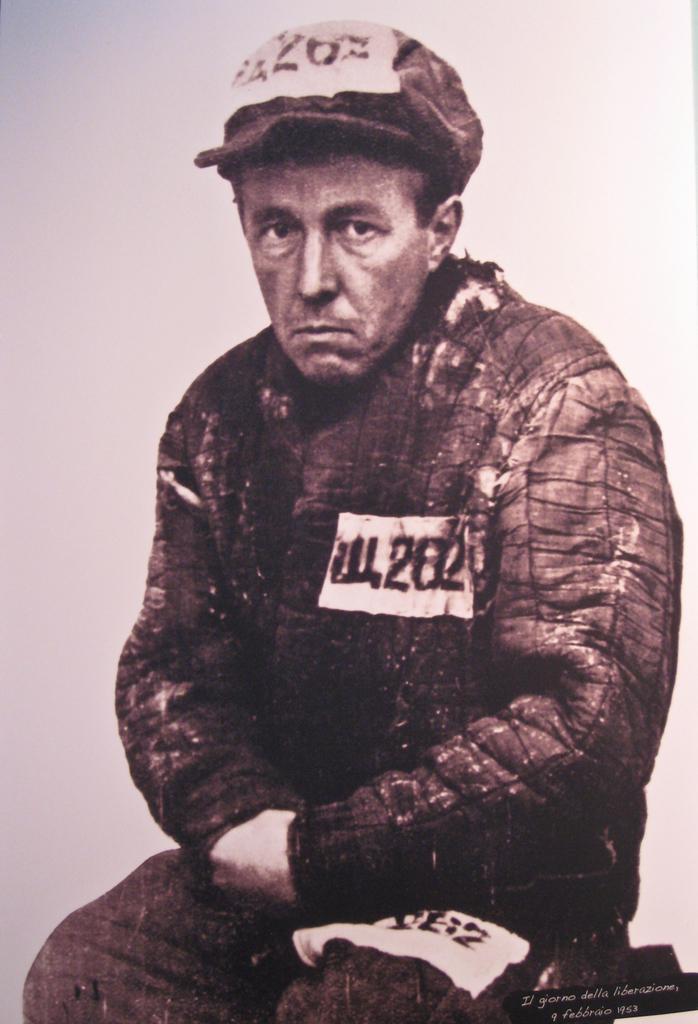In one or two sentences, can you explain what this image depicts? In this image I can see the person sitting and the person is wearing the cap and the image is in black and white. 